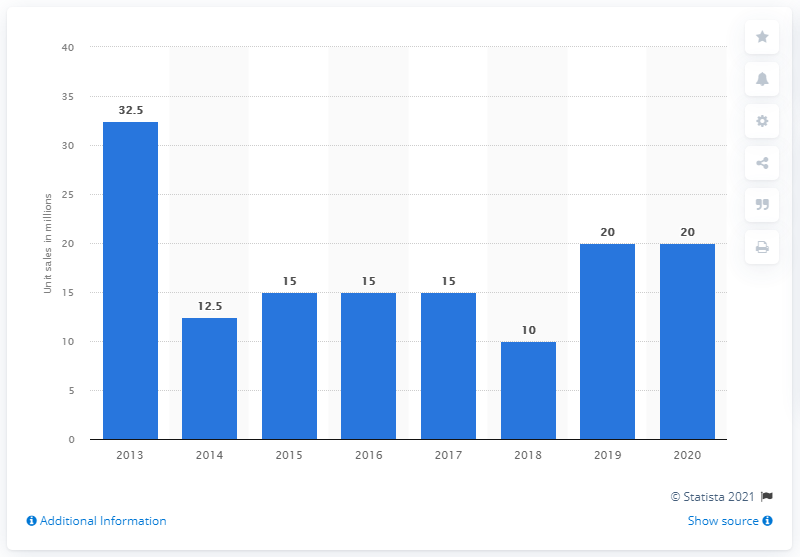Specify some key components in this picture. In 2020, Grand Theft Auto V sold 20 million units. Grand Theft Auto V was released in 2013. 